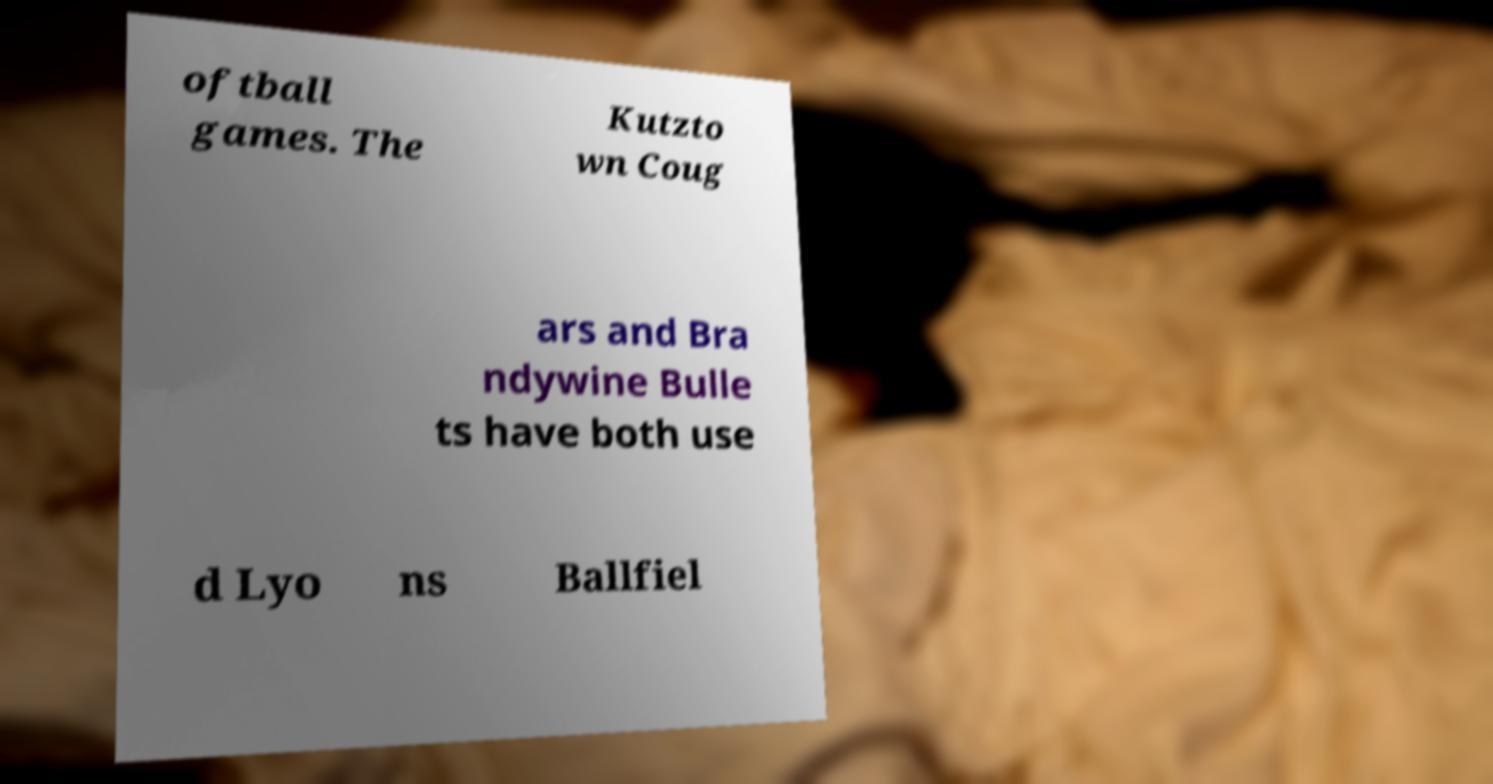Please read and relay the text visible in this image. What does it say? oftball games. The Kutzto wn Coug ars and Bra ndywine Bulle ts have both use d Lyo ns Ballfiel 